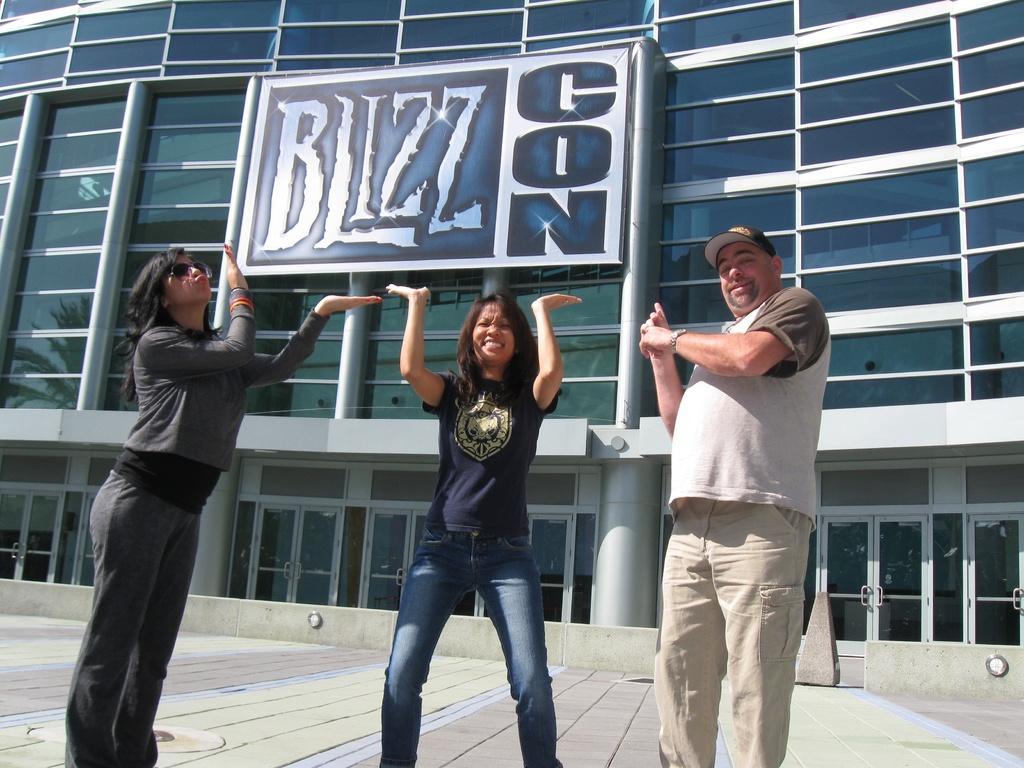Describe this image in one or two sentences. In this image, there are a few people. In the background, we can see the building and a board with some text. We can also see the ground. 